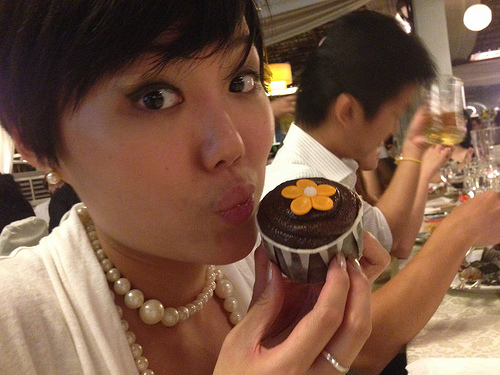Imagine the thoughts of the woman holding the dessert. What could she be thinking? The woman holding the dessert might be thinking about how delicious the cupcake looks and could be looking forward to tasting it. She might be appreciating the decoration on the cupcake, especially the cute flower on top, and feeling happy about the moment. If this image was part of a story, what might the plot revolve around? If this image was part of a story, the plot could revolve around a friend's surprise birthday party at a cozy restaurant. The narrative might explore the preparation of the surprise, the heartwarming reactions of the birthday person, the joyful gathering of friends, and the delightful moments shared over delicious desserts and lively conversations. 